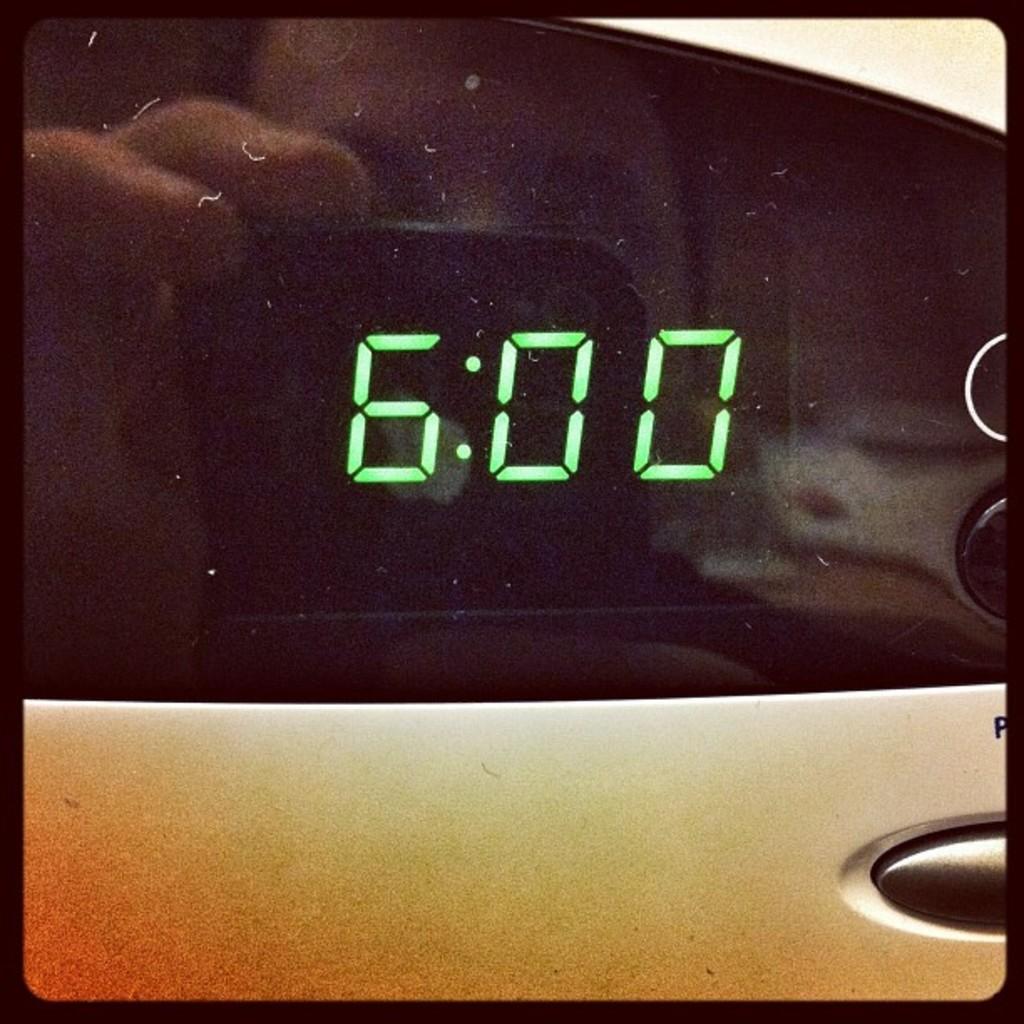What time is shown on the lcd?
Provide a succinct answer. 6:00. 